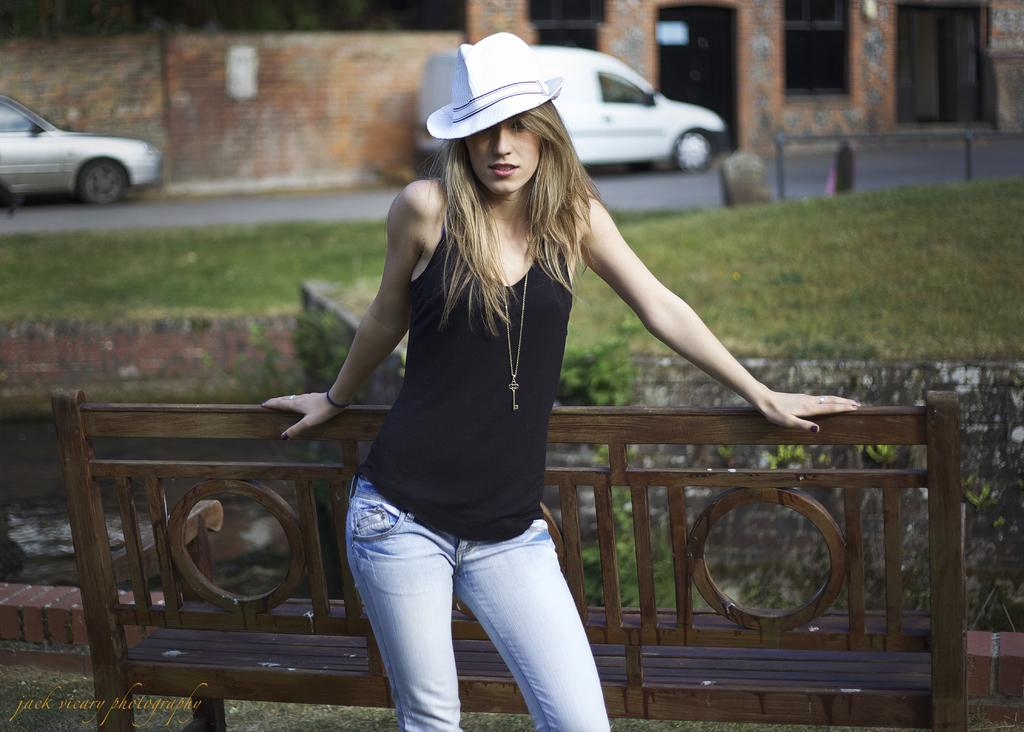Who is present in the image? There is a woman in the image. What is the woman wearing? The woman is wearing a black dress and a white hat. What type of environment is visible in the image? There is grass visible in the image. Are there any man-made structures in the image? Yes, there is a car and a building in the image. Can you tell me how many women are swimming in the river in the image? There is no river or women swimming in the image; it features a woman in a black dress and a white hat, along with a car and a building. 